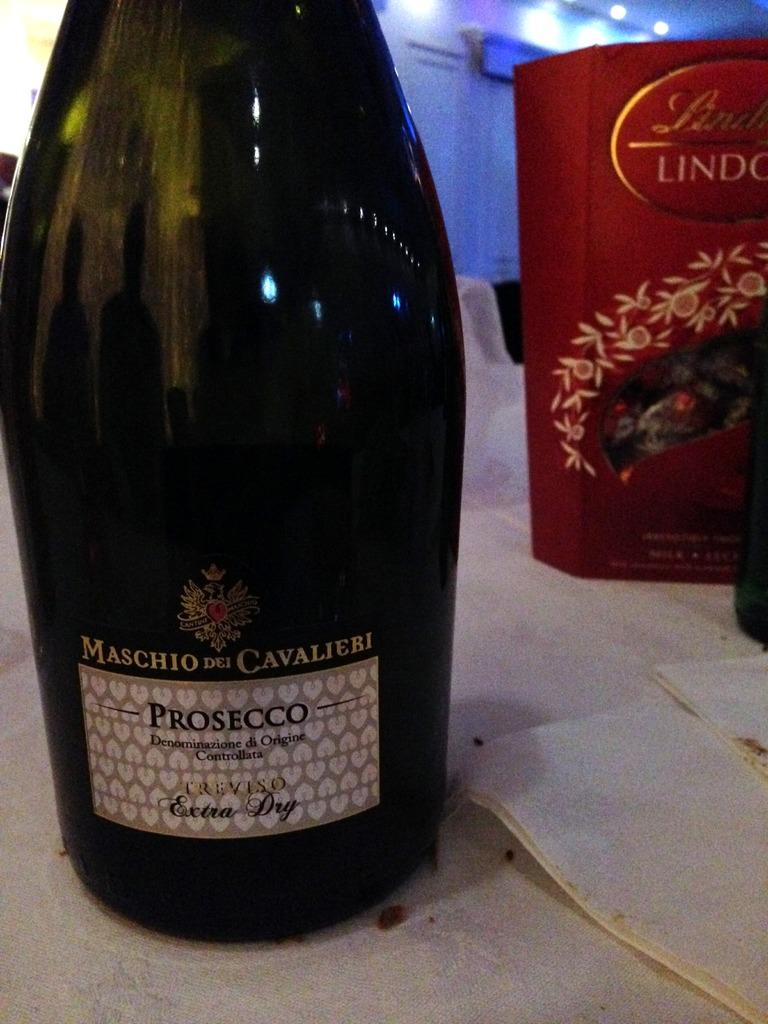<image>
Create a compact narrative representing the image presented. A large wine bottle labeled Maschio Dei Cavalieri sits on a table. 